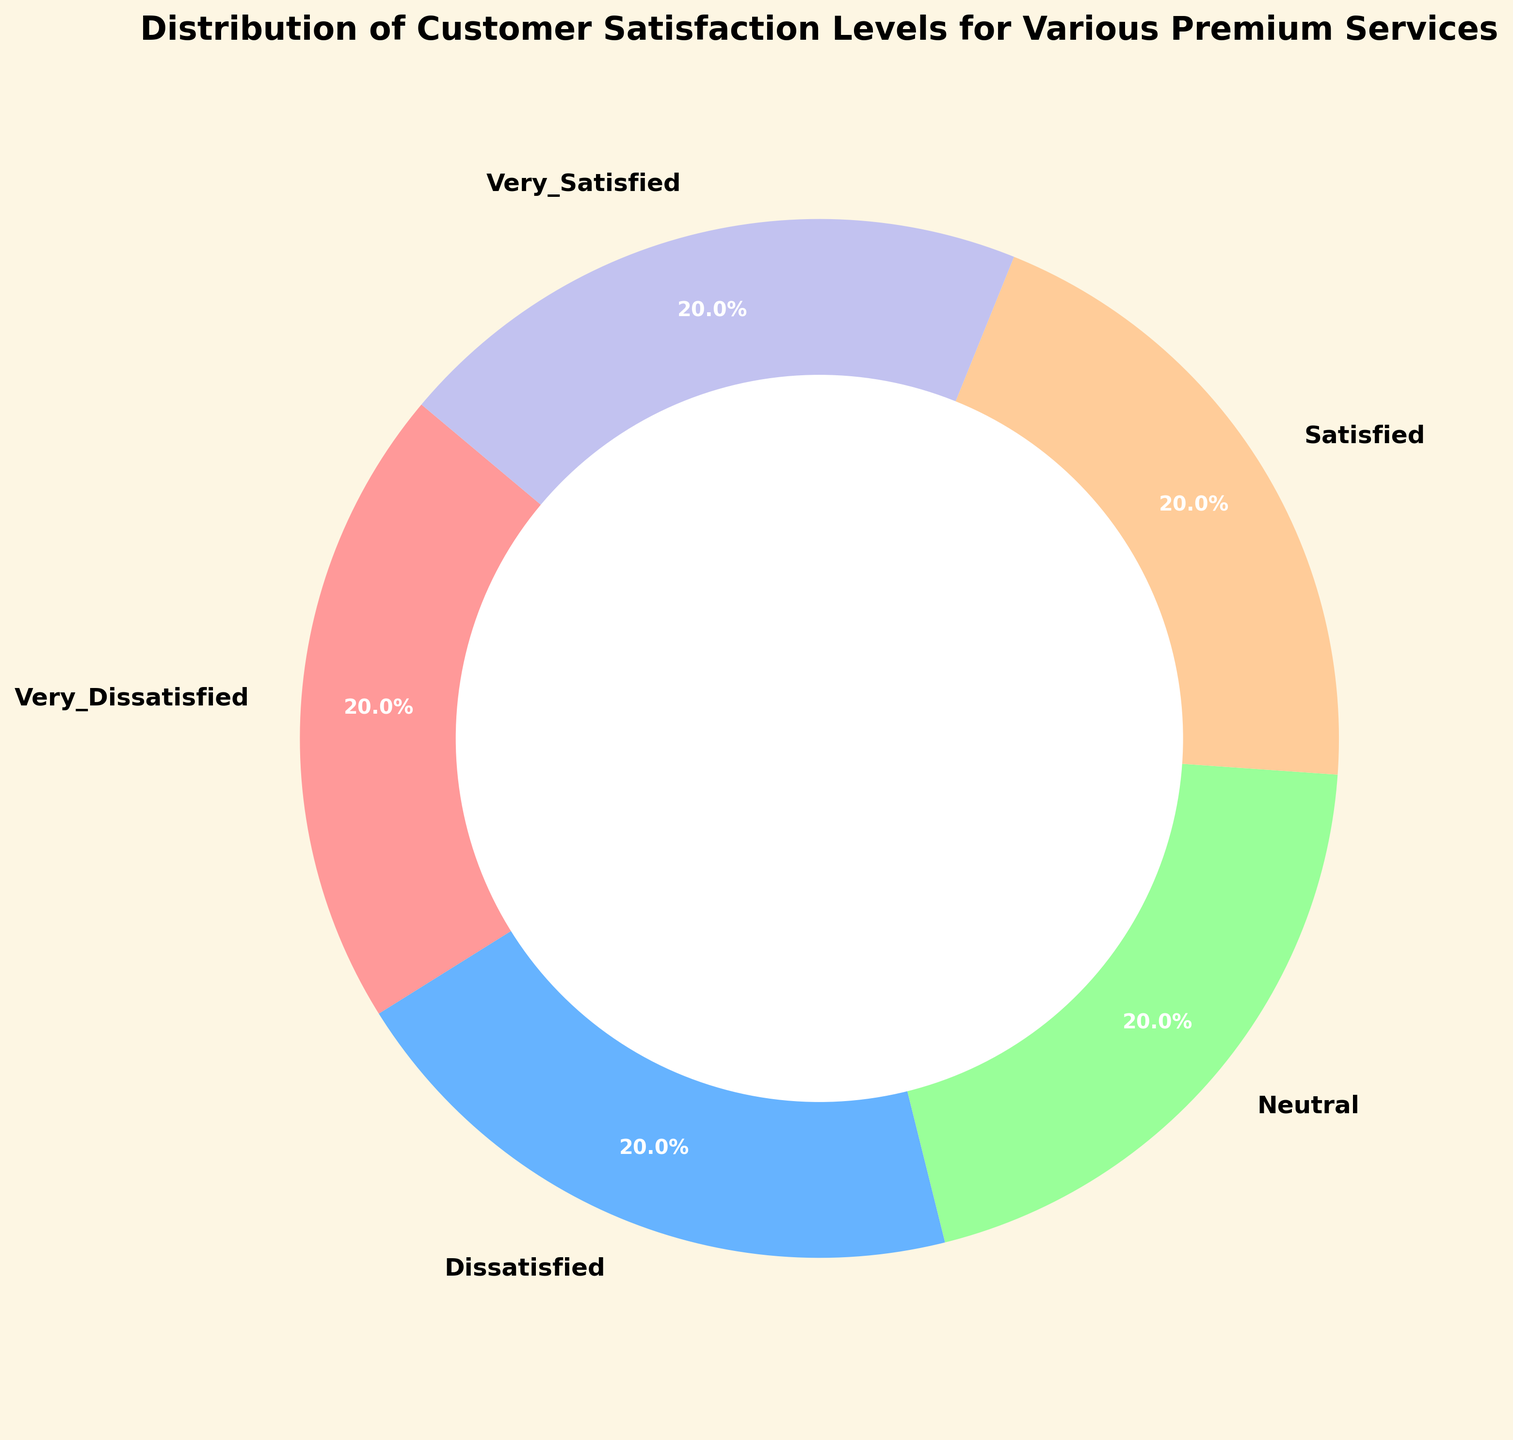Which customer satisfaction level has the smallest segment in the ring chart? To determine the smallest segment, visually inspect the segments of the ring chart and identify the one with the least area.
Answer: Very Dissatisfied Which customer satisfaction level contributes the most to the total distribution for premium services? Visually inspect the ring chart to identify the segment with the largest area. This will be the customer satisfaction level with the highest percentage.
Answer: Very Satisfied How many more percentage points does the "Very Satisfied" level have compared to the "Dissatisfied" level? Identify the percentages from the ring chart for both "Very Satisfied" and "Dissatisfied." Then subtract the percentage of the "Dissatisfied" level from that of the "Very Satisfied" level.
Answer: 60.0 - 5.5 = 54.5 percentage points What is the combined percentage of "Neutral" and "Dissatisfied" satisfaction levels? Identify the percentages from the ring chart for both "Neutral" and "Dissatisfied." Then sum these percentages to get the combined value.
Answer: 7.6% + 5.6% = 13.2% Compare the percentages of "Satisfied" and "Very Dissatisfied" levels. Which one is higher, and by how much? Identify the percentages from the ring chart for both "Satisfied" and "Very Dissatisfied." Then subtract the "Very Dissatisfied" percentage from the "Satisfied" percentage to determine the difference.
Answer: 33.0% - 4.8% = 28.2%, with "Satisfied" being higher What percentage of the total does the "Neutral" satisfaction level occupy? Identify the percentage from the ring chart attributed to the "Neutral" satisfaction level.
Answer: 7.6% Which two satisfaction levels have the most similar percentage distributions? Visually inspect the ring chart to identify the two segments with areas closest in size. Compare their exact percentages if necessary.
Answer: Dissatisfied and Very Dissatisfied What is the difference in percentage between the highest and the lowest customer satisfaction levels? Identify the highest and lowest percentages from the ring chart. Then subtract the lowest percentage from the highest percentage to find the difference.
Answer: 60.0% - 4.8% = 55.2% What is the percentage difference between "Satisfied" and "Neutral?" Identify the percentages from the ring chart for both "Satisfied" and "Neutral." Then subtract the "Neutral" percentage from the "Satisfied" percentage.
Answer: 33.0% - 7.6% = 25.4% What portion of the ring chart does the "Very Satisfied" satisfaction level represent visually? Visually inspect the ring chart and identify the position and size of the "Very Satisfied" segment relative to the whole chart.
Answer: The largest segment, starting at the 140-degree point 